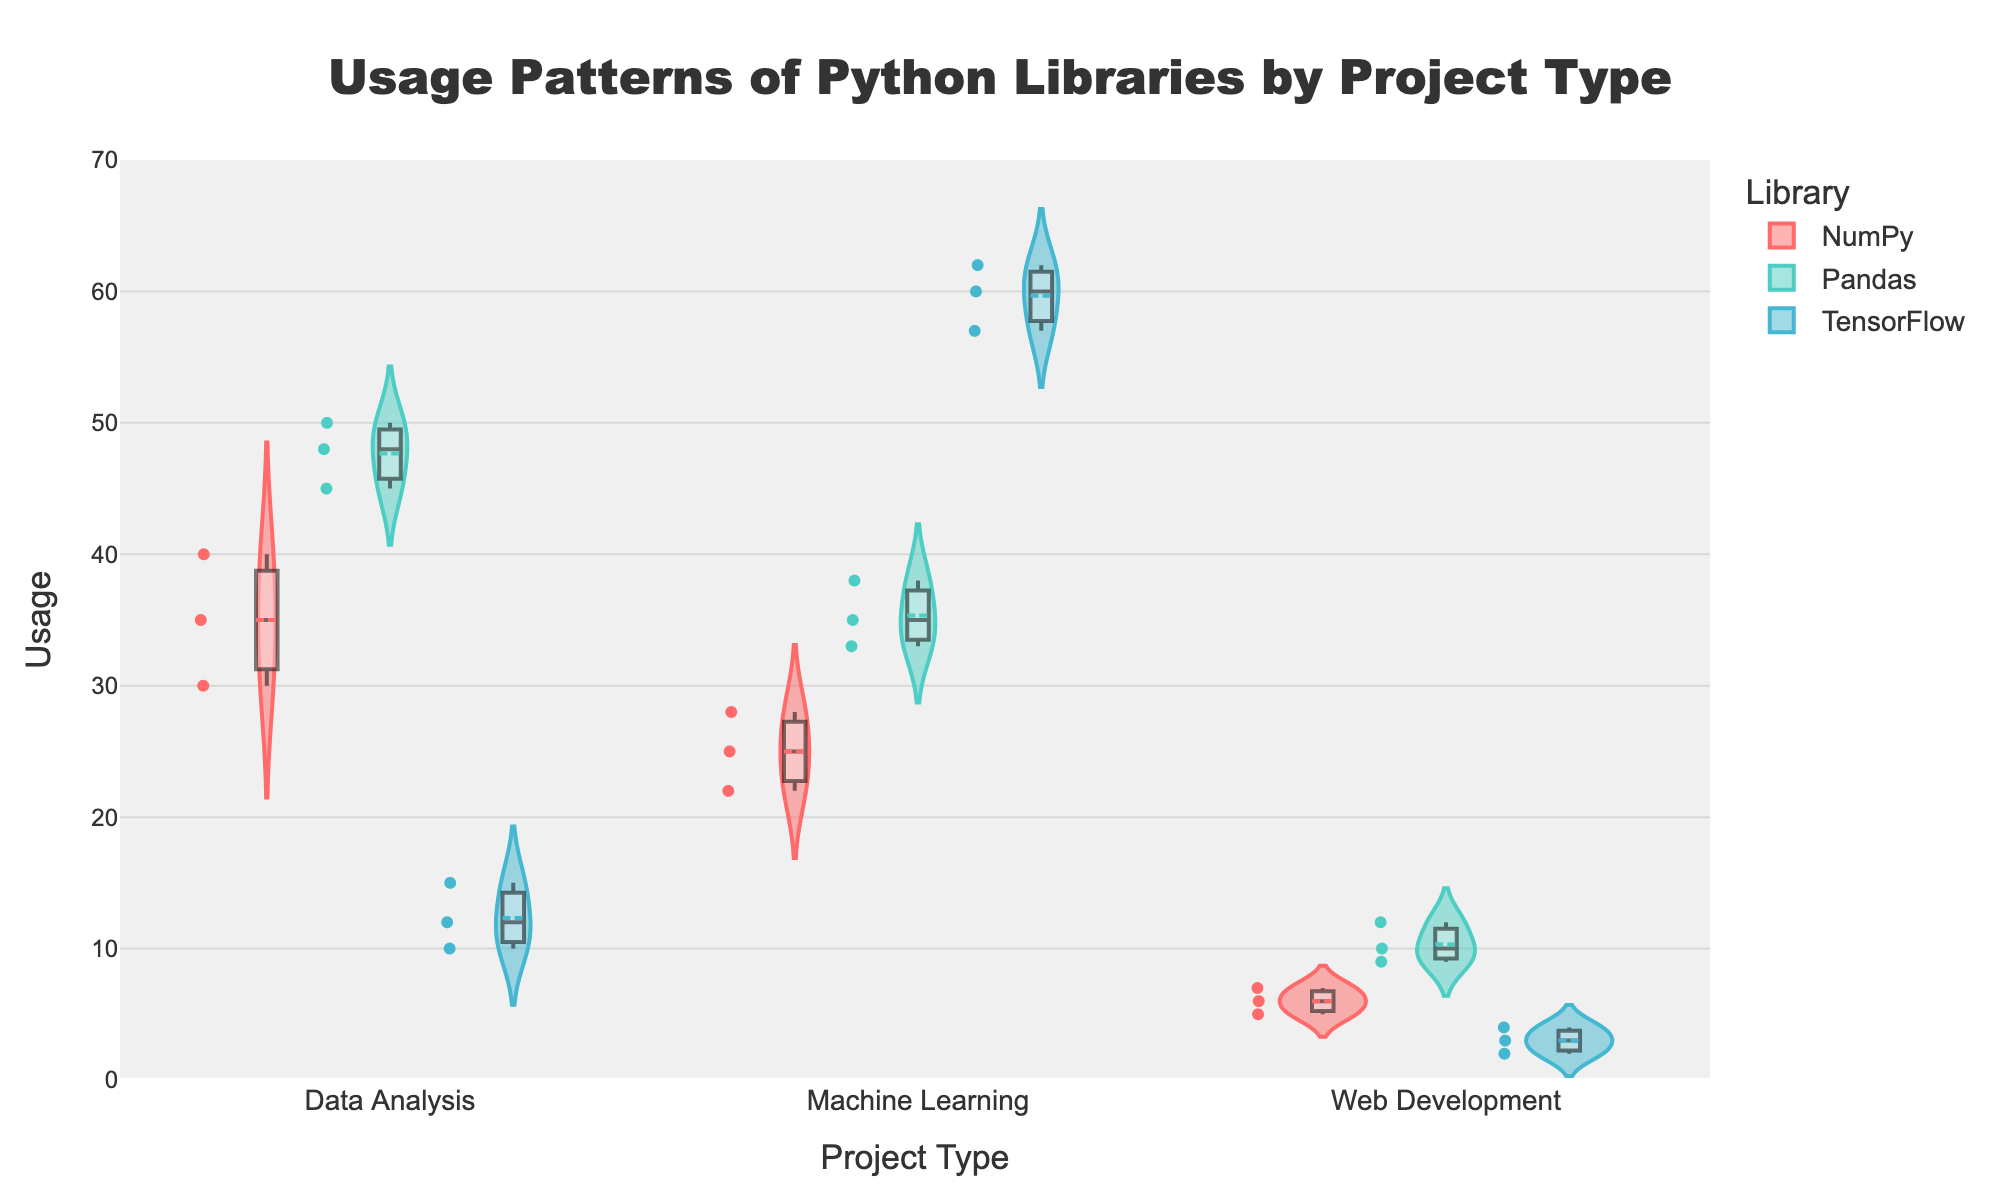Which project type has the highest median usage for TensorFlow? To find the project type with the highest median usage for TensorFlow, look at the median lines within the violin plots for TensorFlow in each project type. The highest median line for TensorFlow is within the Machine Learning project type.
Answer: Machine Learning What is the median usage of Pandas in Data Analysis projects? Check the median line within the violin plot for Pandas under Data Analysis. The median usage of Pandas in Data Analysis projects is around 48.
Answer: 48 Which library has the highest overall usage in Machine Learning projects? Compare the range and density of the usage values within the violin plots for NumPy, Pandas, and TensorFlow under the Machine Learning project type. TensorFlow shows the highest overall usage.
Answer: TensorFlow In which project type is NumPy used the least? Examine the violin plots for NumPy across all project types and identify which has the lowest density and range. The Web Development project type shows the least usage for NumPy.
Answer: Web Development What is the range of usage values for Pandas in Data Analysis projects? To find the range, look at the minimum and maximum values in the violin plot for Pandas under Data Analysis projects. The minimum usage is 45, and the maximum is 50, so the range is 50 - 45 = 5.
Answer: 45-50 How does the usage distribution of TensorFlow differ between Data Analysis and Machine Learning projects? Comparing the shapes and densities of the violin plots for TensorFlow under Data Analysis and Machine Learning projects, TensorFlow's distribution in Data Analysis is more compact and centered around lower values, whereas in Machine Learning, it has a higher and broader distribution, suggesting higher and more varied usage.
Answer: More varied in Machine Learning; higher usage What is the average usage of NumPy in Machine Learning projects? To calculate the average usage of NumPy in Machine Learning projects, sum up the individual usage values and divide by the number of points. The values are 25, 28, and 22. The total is 25 + 28 + 22 = 75. Hence, the average is 75 / 3 = 25.
Answer: 25 Does Pandas have a wider distribution of usage in Data Analysis or Web Development projects? Comparing the widths of the violin plots for Pandas under Data Analysis and Web Development projects, the distribution for Data Analysis is wider, indicating a greater variability in usage.
Answer: Data Analysis What are the maximum and minimum usage values for TensorFlow in Machine Learning projects? Identify the highest and lowest points within the TensorFlow violin plot for Machine Learning projects. The maximum usage value is 62, and the minimum is 57.
Answer: 62, 57 